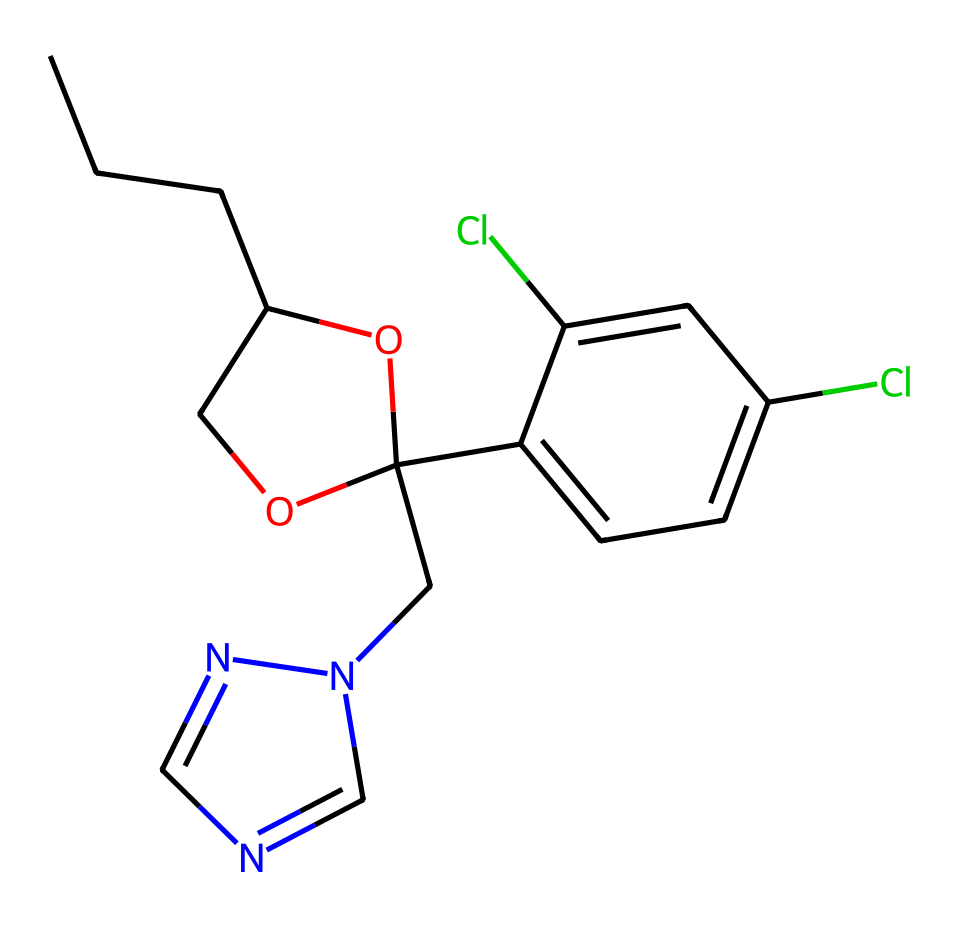How many carbon atoms are present in propiconazole? By analyzing the SMILES representation, each "C" represents a carbon atom. Counting the "C" characters yields a total of 13 carbon atoms in the entire structure.
Answer: 13 What type of functional groups are present in propiconazole? The structure contains ether (-O-), hydroxyl (-OH), and imidazole (n2cncn2) functional groups. These contribute to its biological activity as a fungicide.
Answer: ether, hydroxyl, imidazole How many chlorine atoms are in the chemical structure? The two instances of "Cl" in the SMILES indicate there are two chlorine atoms in this molecule, both found on the aromatic ring of the chemical.
Answer: 2 What is the molecular weight of propiconazole? Using the molecular formula derived from counting the atoms in the SMILES, the molecular weight can be calculated to be approximately 265.7 g/mol, based on common atomic weights of C, H, Cl, N, and O.
Answer: 265.7 g/mol What part of the structure indicates it is a fungicide? The imidazole ring (Cn2cncn2) in this chemical structure is commonly associated with many antifungal agents, allowing it to act on fungal cell pathways.
Answer: imidazole ring What is the main role of the hydroxyl group in this chemical? The presence of the hydroxyl group (-OH) can enhance the solubility and reactivity of propiconazole, affecting its absorption in biological systems and thereby increasing its antifungal efficacy.
Answer: enhance solubility and reactivity 